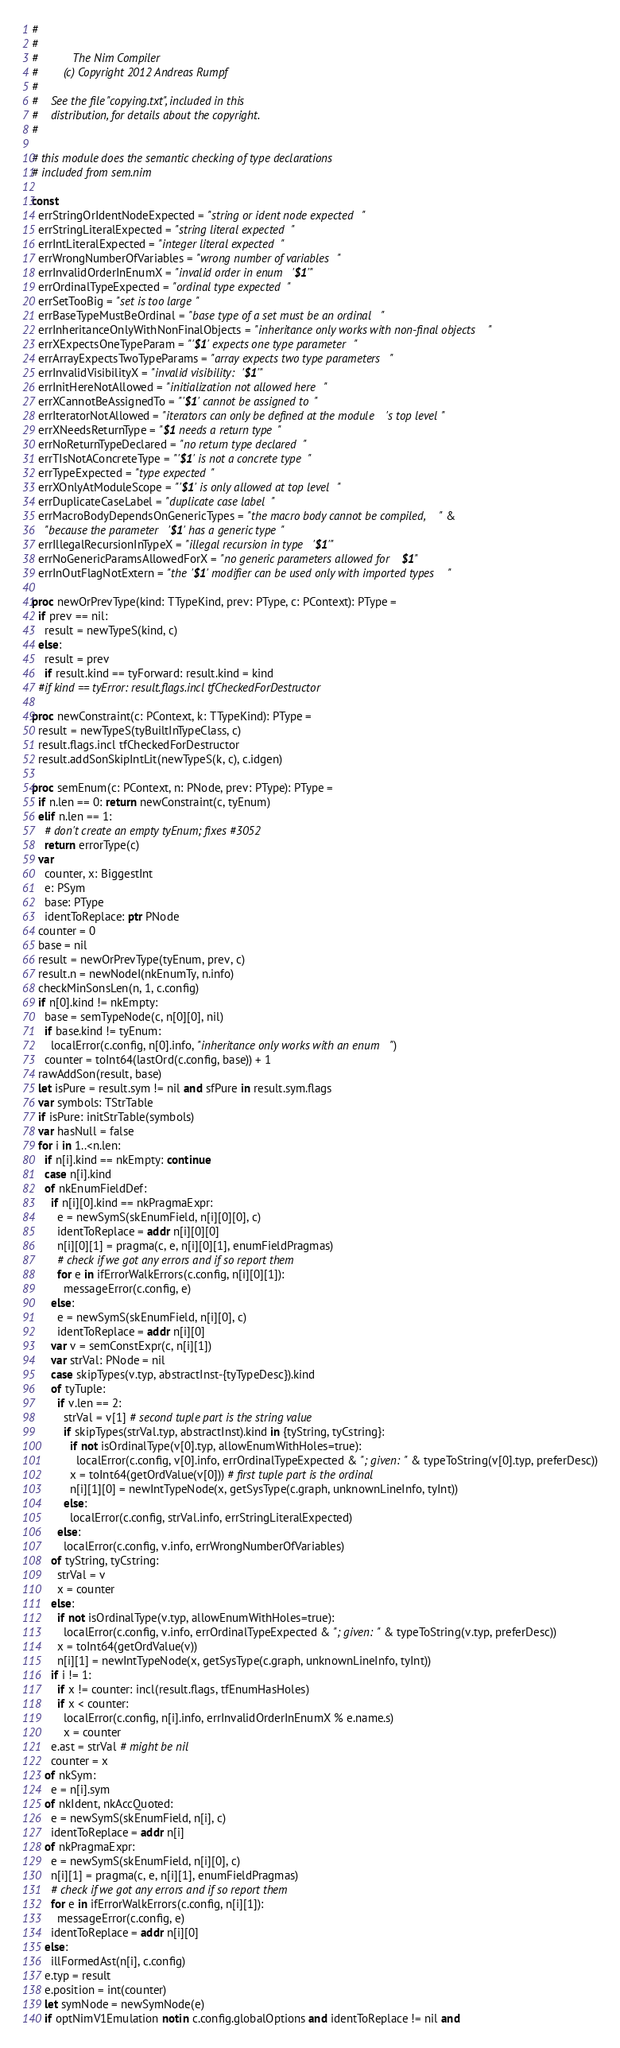Convert code to text. <code><loc_0><loc_0><loc_500><loc_500><_Nim_>#
#
#           The Nim Compiler
#        (c) Copyright 2012 Andreas Rumpf
#
#    See the file "copying.txt", included in this
#    distribution, for details about the copyright.
#

# this module does the semantic checking of type declarations
# included from sem.nim

const
  errStringOrIdentNodeExpected = "string or ident node expected"
  errStringLiteralExpected = "string literal expected"
  errIntLiteralExpected = "integer literal expected"
  errWrongNumberOfVariables = "wrong number of variables"
  errInvalidOrderInEnumX = "invalid order in enum '$1'"
  errOrdinalTypeExpected = "ordinal type expected"
  errSetTooBig = "set is too large"
  errBaseTypeMustBeOrdinal = "base type of a set must be an ordinal"
  errInheritanceOnlyWithNonFinalObjects = "inheritance only works with non-final objects"
  errXExpectsOneTypeParam = "'$1' expects one type parameter"
  errArrayExpectsTwoTypeParams = "array expects two type parameters"
  errInvalidVisibilityX = "invalid visibility: '$1'"
  errInitHereNotAllowed = "initialization not allowed here"
  errXCannotBeAssignedTo = "'$1' cannot be assigned to"
  errIteratorNotAllowed = "iterators can only be defined at the module's top level"
  errXNeedsReturnType = "$1 needs a return type"
  errNoReturnTypeDeclared = "no return type declared"
  errTIsNotAConcreteType = "'$1' is not a concrete type"
  errTypeExpected = "type expected"
  errXOnlyAtModuleScope = "'$1' is only allowed at top level"
  errDuplicateCaseLabel = "duplicate case label"
  errMacroBodyDependsOnGenericTypes = "the macro body cannot be compiled, " &
    "because the parameter '$1' has a generic type"
  errIllegalRecursionInTypeX = "illegal recursion in type '$1'"
  errNoGenericParamsAllowedForX = "no generic parameters allowed for $1"
  errInOutFlagNotExtern = "the '$1' modifier can be used only with imported types"

proc newOrPrevType(kind: TTypeKind, prev: PType, c: PContext): PType =
  if prev == nil:
    result = newTypeS(kind, c)
  else:
    result = prev
    if result.kind == tyForward: result.kind = kind
  #if kind == tyError: result.flags.incl tfCheckedForDestructor

proc newConstraint(c: PContext, k: TTypeKind): PType =
  result = newTypeS(tyBuiltInTypeClass, c)
  result.flags.incl tfCheckedForDestructor
  result.addSonSkipIntLit(newTypeS(k, c), c.idgen)

proc semEnum(c: PContext, n: PNode, prev: PType): PType =
  if n.len == 0: return newConstraint(c, tyEnum)
  elif n.len == 1:
    # don't create an empty tyEnum; fixes #3052
    return errorType(c)
  var
    counter, x: BiggestInt
    e: PSym
    base: PType
    identToReplace: ptr PNode
  counter = 0
  base = nil
  result = newOrPrevType(tyEnum, prev, c)
  result.n = newNodeI(nkEnumTy, n.info)
  checkMinSonsLen(n, 1, c.config)
  if n[0].kind != nkEmpty:
    base = semTypeNode(c, n[0][0], nil)
    if base.kind != tyEnum:
      localError(c.config, n[0].info, "inheritance only works with an enum")
    counter = toInt64(lastOrd(c.config, base)) + 1
  rawAddSon(result, base)
  let isPure = result.sym != nil and sfPure in result.sym.flags
  var symbols: TStrTable
  if isPure: initStrTable(symbols)
  var hasNull = false
  for i in 1..<n.len:
    if n[i].kind == nkEmpty: continue
    case n[i].kind
    of nkEnumFieldDef:
      if n[i][0].kind == nkPragmaExpr:
        e = newSymS(skEnumField, n[i][0][0], c)
        identToReplace = addr n[i][0][0]
        n[i][0][1] = pragma(c, e, n[i][0][1], enumFieldPragmas)
        # check if we got any errors and if so report them
        for e in ifErrorWalkErrors(c.config, n[i][0][1]):
          messageError(c.config, e)
      else:
        e = newSymS(skEnumField, n[i][0], c)
        identToReplace = addr n[i][0]
      var v = semConstExpr(c, n[i][1])
      var strVal: PNode = nil
      case skipTypes(v.typ, abstractInst-{tyTypeDesc}).kind
      of tyTuple:
        if v.len == 2:
          strVal = v[1] # second tuple part is the string value
          if skipTypes(strVal.typ, abstractInst).kind in {tyString, tyCstring}:
            if not isOrdinalType(v[0].typ, allowEnumWithHoles=true):
              localError(c.config, v[0].info, errOrdinalTypeExpected & "; given: " & typeToString(v[0].typ, preferDesc))
            x = toInt64(getOrdValue(v[0])) # first tuple part is the ordinal
            n[i][1][0] = newIntTypeNode(x, getSysType(c.graph, unknownLineInfo, tyInt))
          else:
            localError(c.config, strVal.info, errStringLiteralExpected)
        else:
          localError(c.config, v.info, errWrongNumberOfVariables)
      of tyString, tyCstring:
        strVal = v
        x = counter
      else:
        if not isOrdinalType(v.typ, allowEnumWithHoles=true):
          localError(c.config, v.info, errOrdinalTypeExpected & "; given: " & typeToString(v.typ, preferDesc))
        x = toInt64(getOrdValue(v))
        n[i][1] = newIntTypeNode(x, getSysType(c.graph, unknownLineInfo, tyInt))
      if i != 1:
        if x != counter: incl(result.flags, tfEnumHasHoles)
        if x < counter:
          localError(c.config, n[i].info, errInvalidOrderInEnumX % e.name.s)
          x = counter
      e.ast = strVal # might be nil
      counter = x
    of nkSym:
      e = n[i].sym
    of nkIdent, nkAccQuoted:
      e = newSymS(skEnumField, n[i], c)
      identToReplace = addr n[i]
    of nkPragmaExpr:
      e = newSymS(skEnumField, n[i][0], c)
      n[i][1] = pragma(c, e, n[i][1], enumFieldPragmas)
      # check if we got any errors and if so report them
      for e in ifErrorWalkErrors(c.config, n[i][1]):
        messageError(c.config, e)
      identToReplace = addr n[i][0]
    else:
      illFormedAst(n[i], c.config)
    e.typ = result
    e.position = int(counter)
    let symNode = newSymNode(e)
    if optNimV1Emulation notin c.config.globalOptions and identToReplace != nil and</code> 